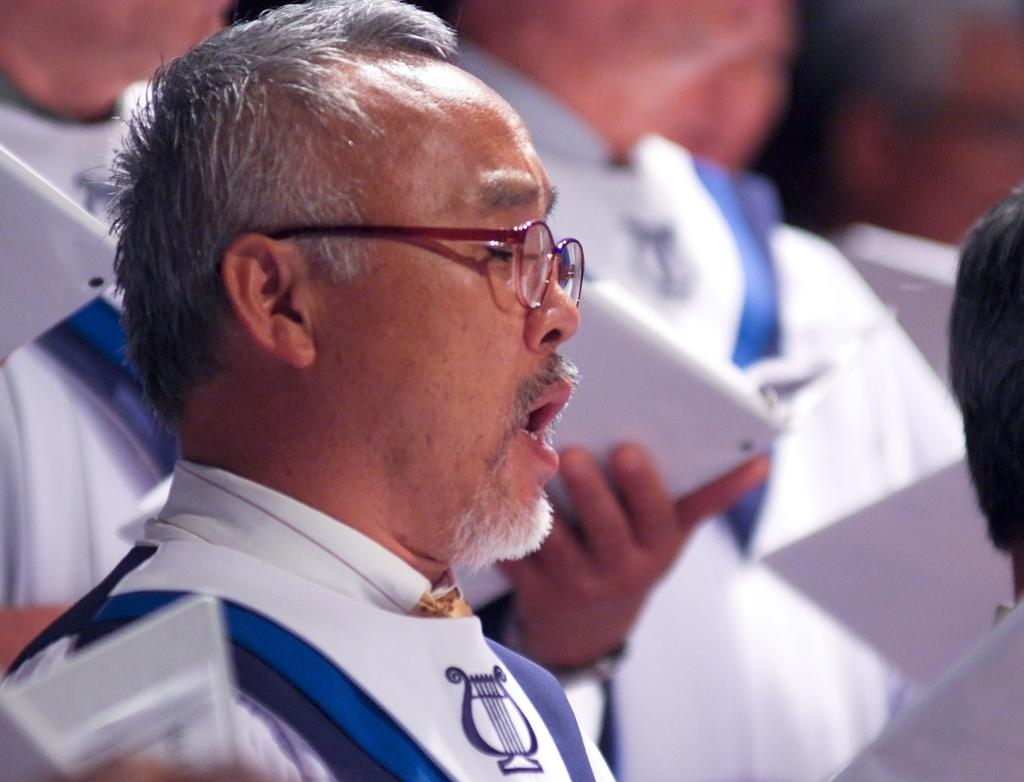How many people are in the image? There are few persons in the image. What are the people wearing in the image? The persons are wearing white dress. What activity are the people engaged in? The persons appear to be offering prayers. What type of vegetable is being twisted by the person in the image? There is no vegetable or twisting action present in the image; the people are offering prayers while wearing white dresses. 